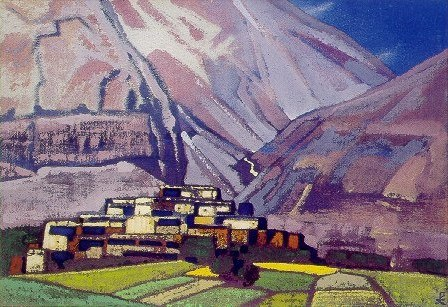What time of day does the image seem to represent and why? The image seems to capture either early morning or late afternoon. The long shadows and the way light seems to wash over the mountains and village suggest a low sun, typical of these times in a day. The warm hues on the buildings' roofs and the brightly lit patches of green land also contribute to this impression, creating a dynamic contrast with the cooler shadows in the folds of the mountains. 